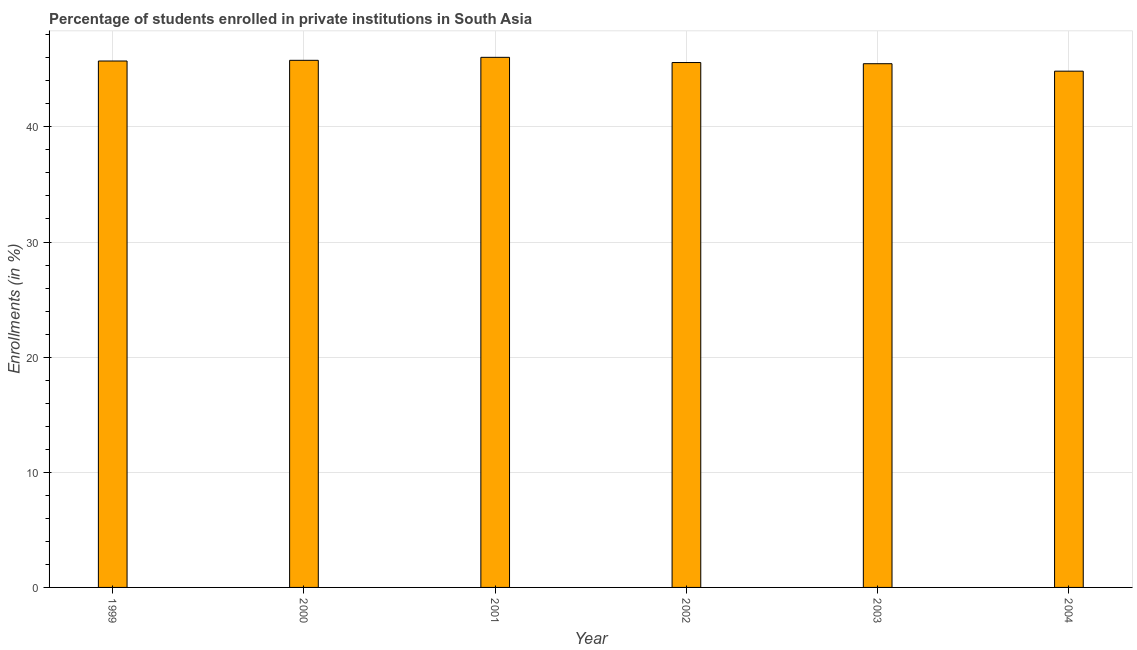Does the graph contain any zero values?
Give a very brief answer. No. Does the graph contain grids?
Provide a short and direct response. Yes. What is the title of the graph?
Make the answer very short. Percentage of students enrolled in private institutions in South Asia. What is the label or title of the Y-axis?
Provide a short and direct response. Enrollments (in %). What is the enrollments in private institutions in 2002?
Keep it short and to the point. 45.59. Across all years, what is the maximum enrollments in private institutions?
Give a very brief answer. 46.04. Across all years, what is the minimum enrollments in private institutions?
Provide a succinct answer. 44.84. What is the sum of the enrollments in private institutions?
Offer a very short reply. 273.45. What is the difference between the enrollments in private institutions in 2000 and 2004?
Provide a succinct answer. 0.94. What is the average enrollments in private institutions per year?
Offer a terse response. 45.57. What is the median enrollments in private institutions?
Your answer should be compact. 45.65. Do a majority of the years between 2003 and 2000 (inclusive) have enrollments in private institutions greater than 10 %?
Your answer should be compact. Yes. What is the difference between the highest and the second highest enrollments in private institutions?
Make the answer very short. 0.26. What is the difference between the highest and the lowest enrollments in private institutions?
Offer a very short reply. 1.2. In how many years, is the enrollments in private institutions greater than the average enrollments in private institutions taken over all years?
Give a very brief answer. 4. How many bars are there?
Your answer should be compact. 6. How many years are there in the graph?
Your response must be concise. 6. What is the difference between two consecutive major ticks on the Y-axis?
Make the answer very short. 10. What is the Enrollments (in %) of 1999?
Offer a terse response. 45.72. What is the Enrollments (in %) in 2000?
Your answer should be very brief. 45.78. What is the Enrollments (in %) of 2001?
Offer a terse response. 46.04. What is the Enrollments (in %) in 2002?
Your answer should be very brief. 45.59. What is the Enrollments (in %) in 2003?
Make the answer very short. 45.48. What is the Enrollments (in %) in 2004?
Provide a short and direct response. 44.84. What is the difference between the Enrollments (in %) in 1999 and 2000?
Provide a short and direct response. -0.06. What is the difference between the Enrollments (in %) in 1999 and 2001?
Ensure brevity in your answer.  -0.32. What is the difference between the Enrollments (in %) in 1999 and 2002?
Provide a succinct answer. 0.13. What is the difference between the Enrollments (in %) in 1999 and 2003?
Keep it short and to the point. 0.23. What is the difference between the Enrollments (in %) in 1999 and 2004?
Make the answer very short. 0.88. What is the difference between the Enrollments (in %) in 2000 and 2001?
Keep it short and to the point. -0.26. What is the difference between the Enrollments (in %) in 2000 and 2002?
Your answer should be compact. 0.19. What is the difference between the Enrollments (in %) in 2000 and 2003?
Provide a succinct answer. 0.29. What is the difference between the Enrollments (in %) in 2000 and 2004?
Your response must be concise. 0.94. What is the difference between the Enrollments (in %) in 2001 and 2002?
Ensure brevity in your answer.  0.45. What is the difference between the Enrollments (in %) in 2001 and 2003?
Your answer should be compact. 0.55. What is the difference between the Enrollments (in %) in 2001 and 2004?
Offer a terse response. 1.2. What is the difference between the Enrollments (in %) in 2002 and 2003?
Your answer should be very brief. 0.1. What is the difference between the Enrollments (in %) in 2002 and 2004?
Provide a short and direct response. 0.75. What is the difference between the Enrollments (in %) in 2003 and 2004?
Give a very brief answer. 0.65. What is the ratio of the Enrollments (in %) in 1999 to that in 2001?
Provide a short and direct response. 0.99. What is the ratio of the Enrollments (in %) in 2000 to that in 2003?
Ensure brevity in your answer.  1.01. What is the ratio of the Enrollments (in %) in 2000 to that in 2004?
Provide a succinct answer. 1.02. What is the ratio of the Enrollments (in %) in 2001 to that in 2002?
Your response must be concise. 1.01. What is the ratio of the Enrollments (in %) in 2001 to that in 2003?
Provide a succinct answer. 1.01. What is the ratio of the Enrollments (in %) in 2001 to that in 2004?
Give a very brief answer. 1.03. 